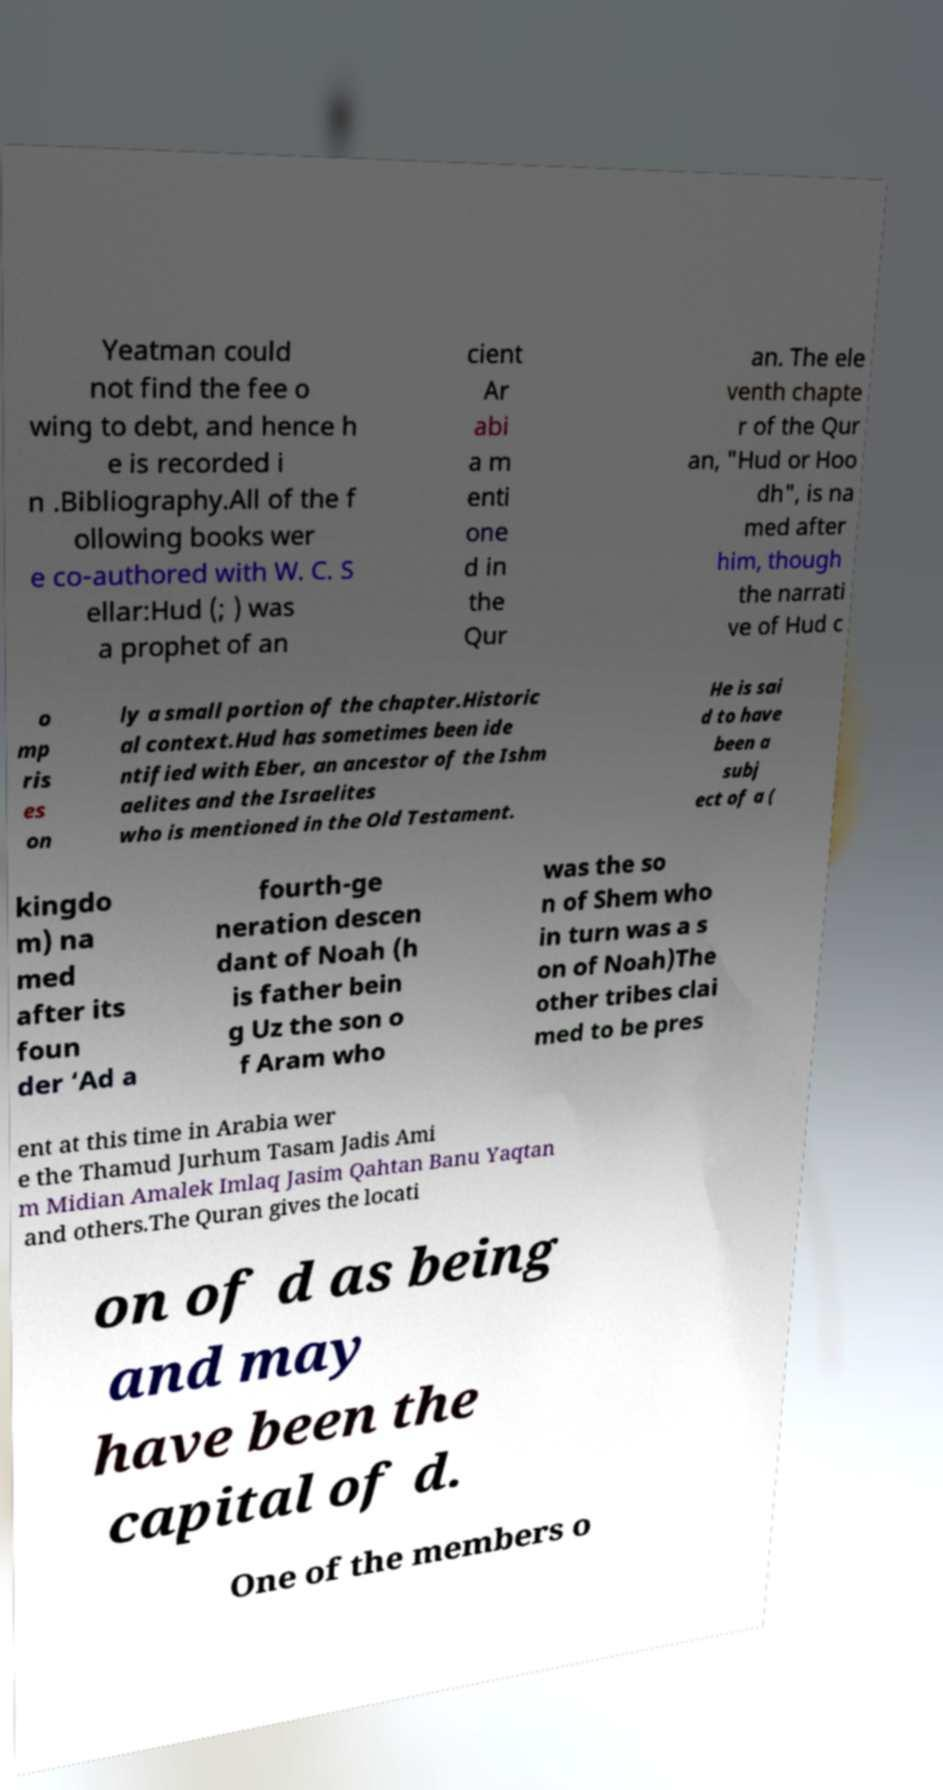Could you assist in decoding the text presented in this image and type it out clearly? Yeatman could not find the fee o wing to debt, and hence h e is recorded i n .Bibliography.All of the f ollowing books wer e co-authored with W. C. S ellar:Hud (; ) was a prophet of an cient Ar abi a m enti one d in the Qur an. The ele venth chapte r of the Qur an, "Hud or Hoo dh", is na med after him, though the narrati ve of Hud c o mp ris es on ly a small portion of the chapter.Historic al context.Hud has sometimes been ide ntified with Eber, an ancestor of the Ishm aelites and the Israelites who is mentioned in the Old Testament. He is sai d to have been a subj ect of a ( kingdo m) na med after its foun der ‘Ad a fourth-ge neration descen dant of Noah (h is father bein g Uz the son o f Aram who was the so n of Shem who in turn was a s on of Noah)The other tribes clai med to be pres ent at this time in Arabia wer e the Thamud Jurhum Tasam Jadis Ami m Midian Amalek Imlaq Jasim Qahtan Banu Yaqtan and others.The Quran gives the locati on of d as being and may have been the capital of d. One of the members o 